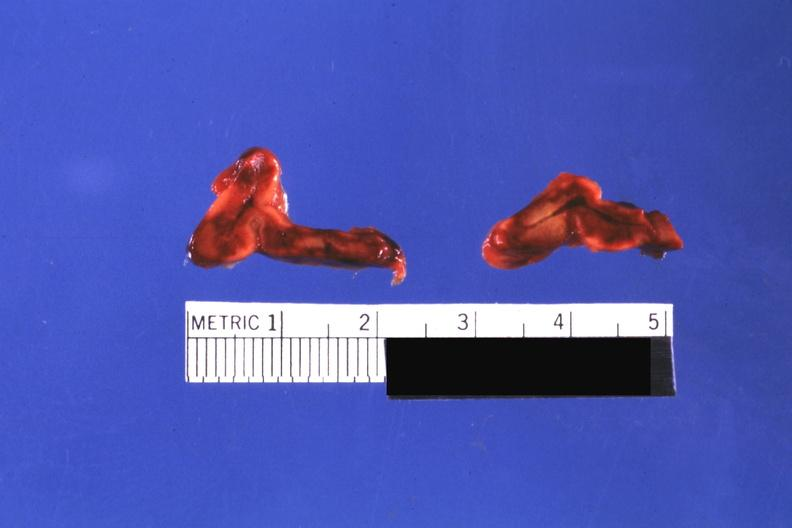what do focal hemorrhagic infarction well shown?
Answer the question using a single word or phrase. Not know history 